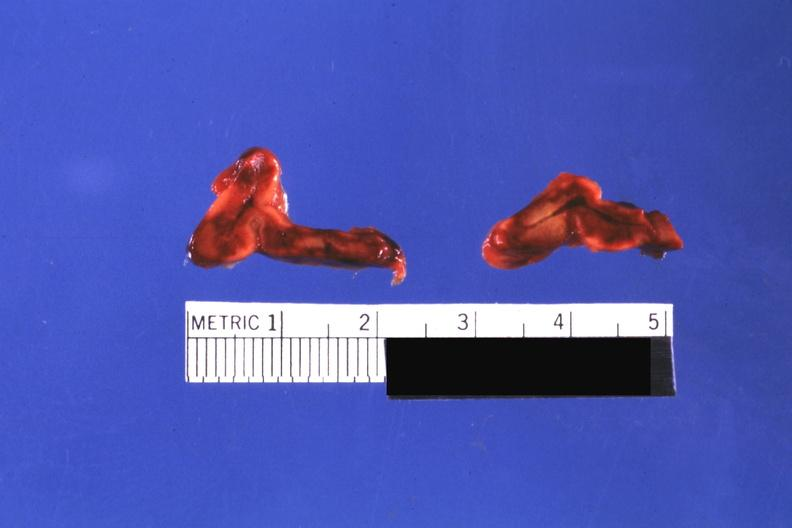what do focal hemorrhagic infarction well shown?
Answer the question using a single word or phrase. Not know history 